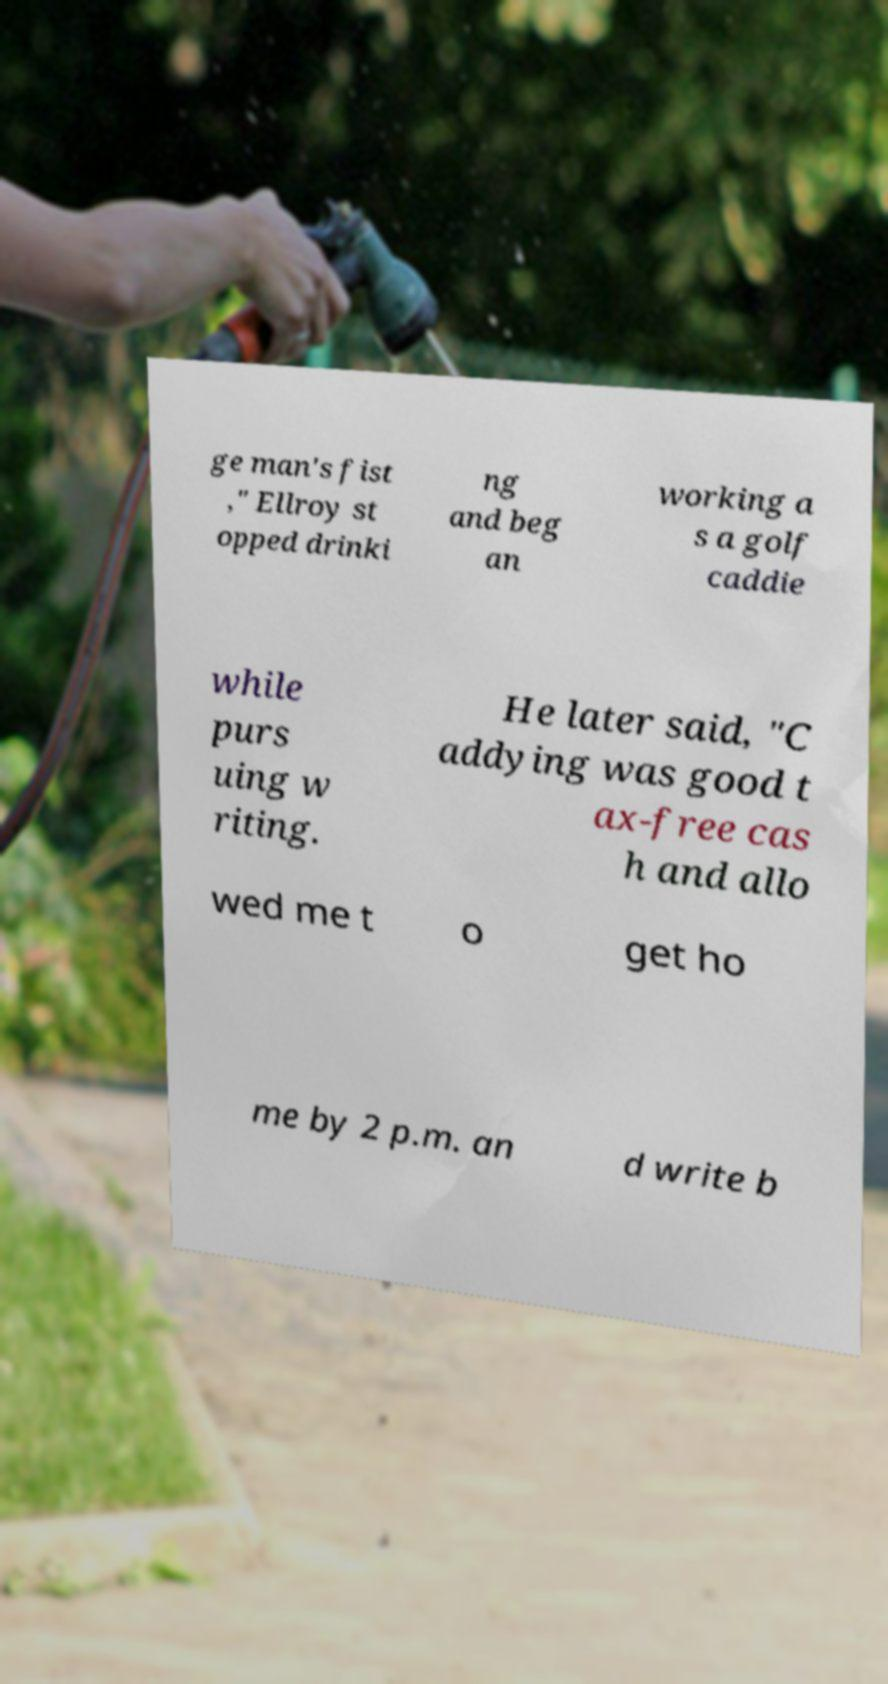Could you extract and type out the text from this image? ge man's fist ," Ellroy st opped drinki ng and beg an working a s a golf caddie while purs uing w riting. He later said, "C addying was good t ax-free cas h and allo wed me t o get ho me by 2 p.m. an d write b 